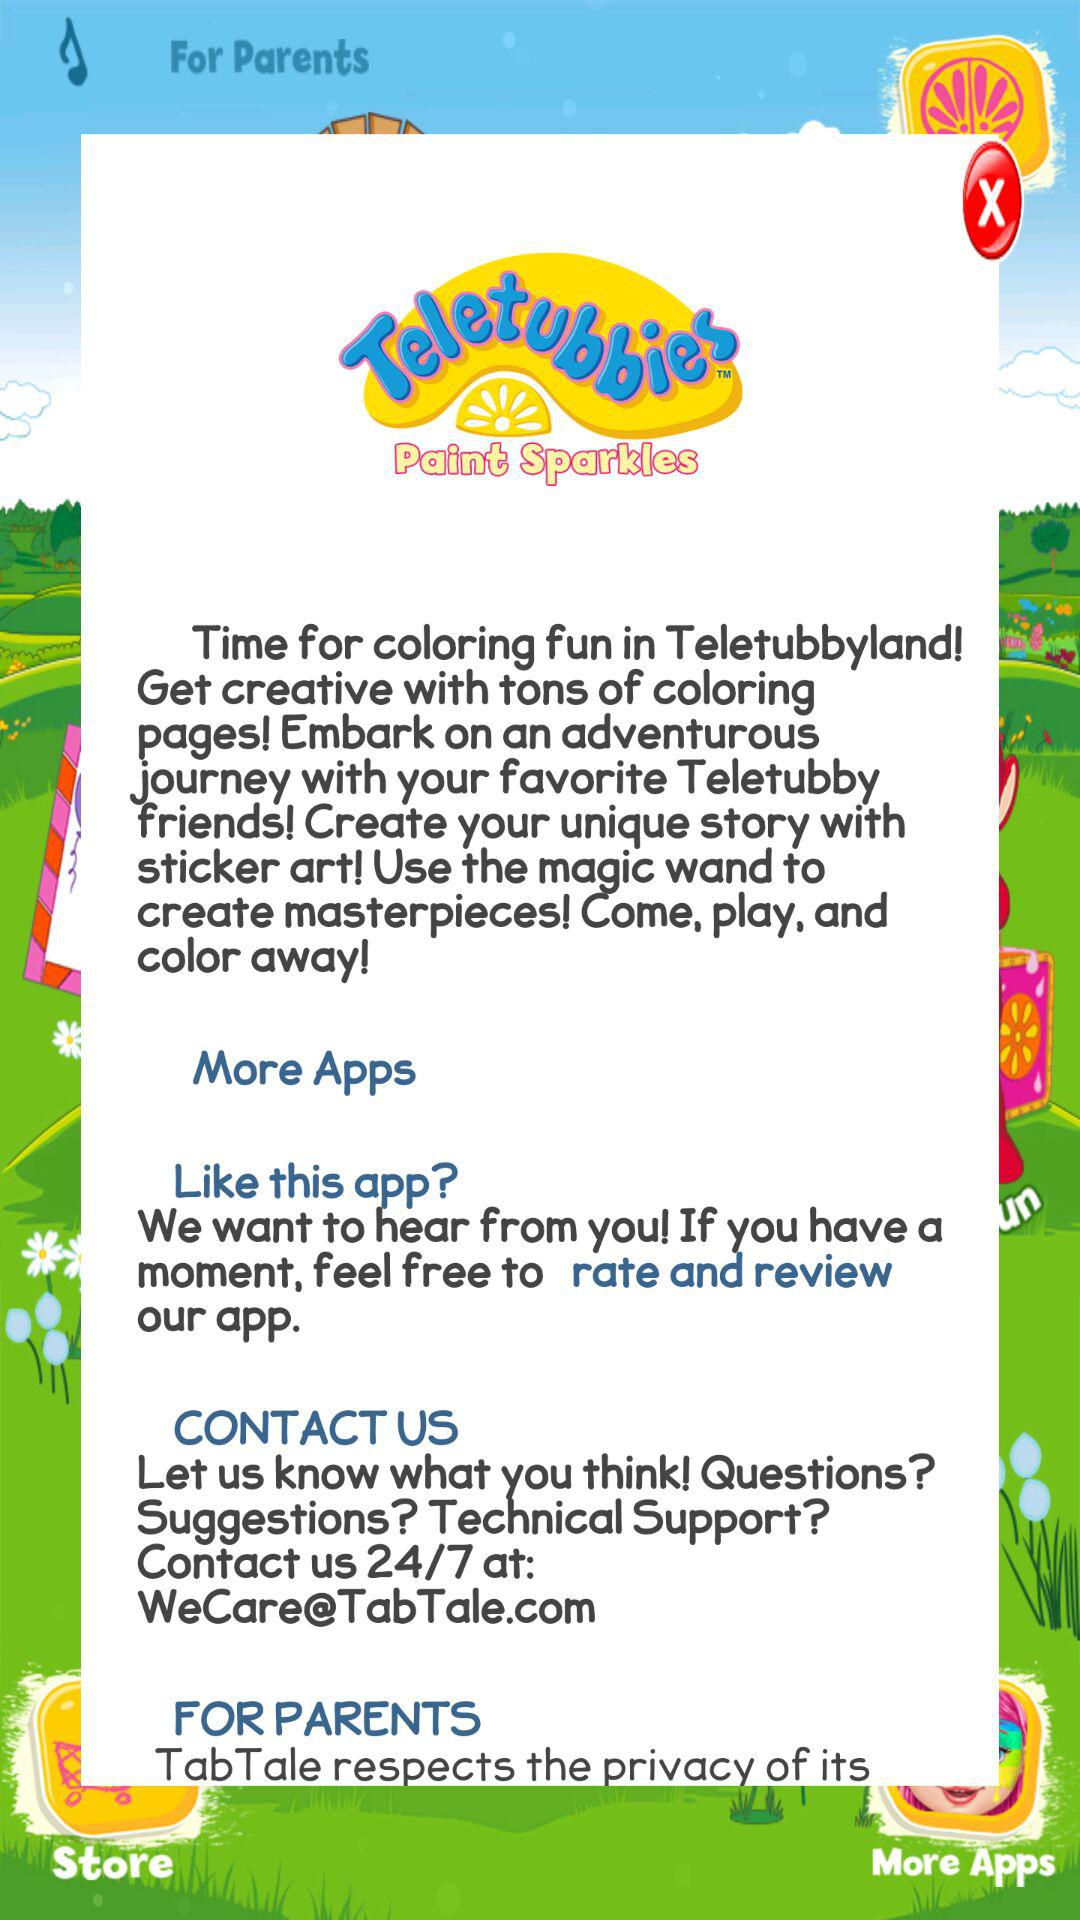How many reviews does the application have?
When the provided information is insufficient, respond with <no answer>. <no answer> 